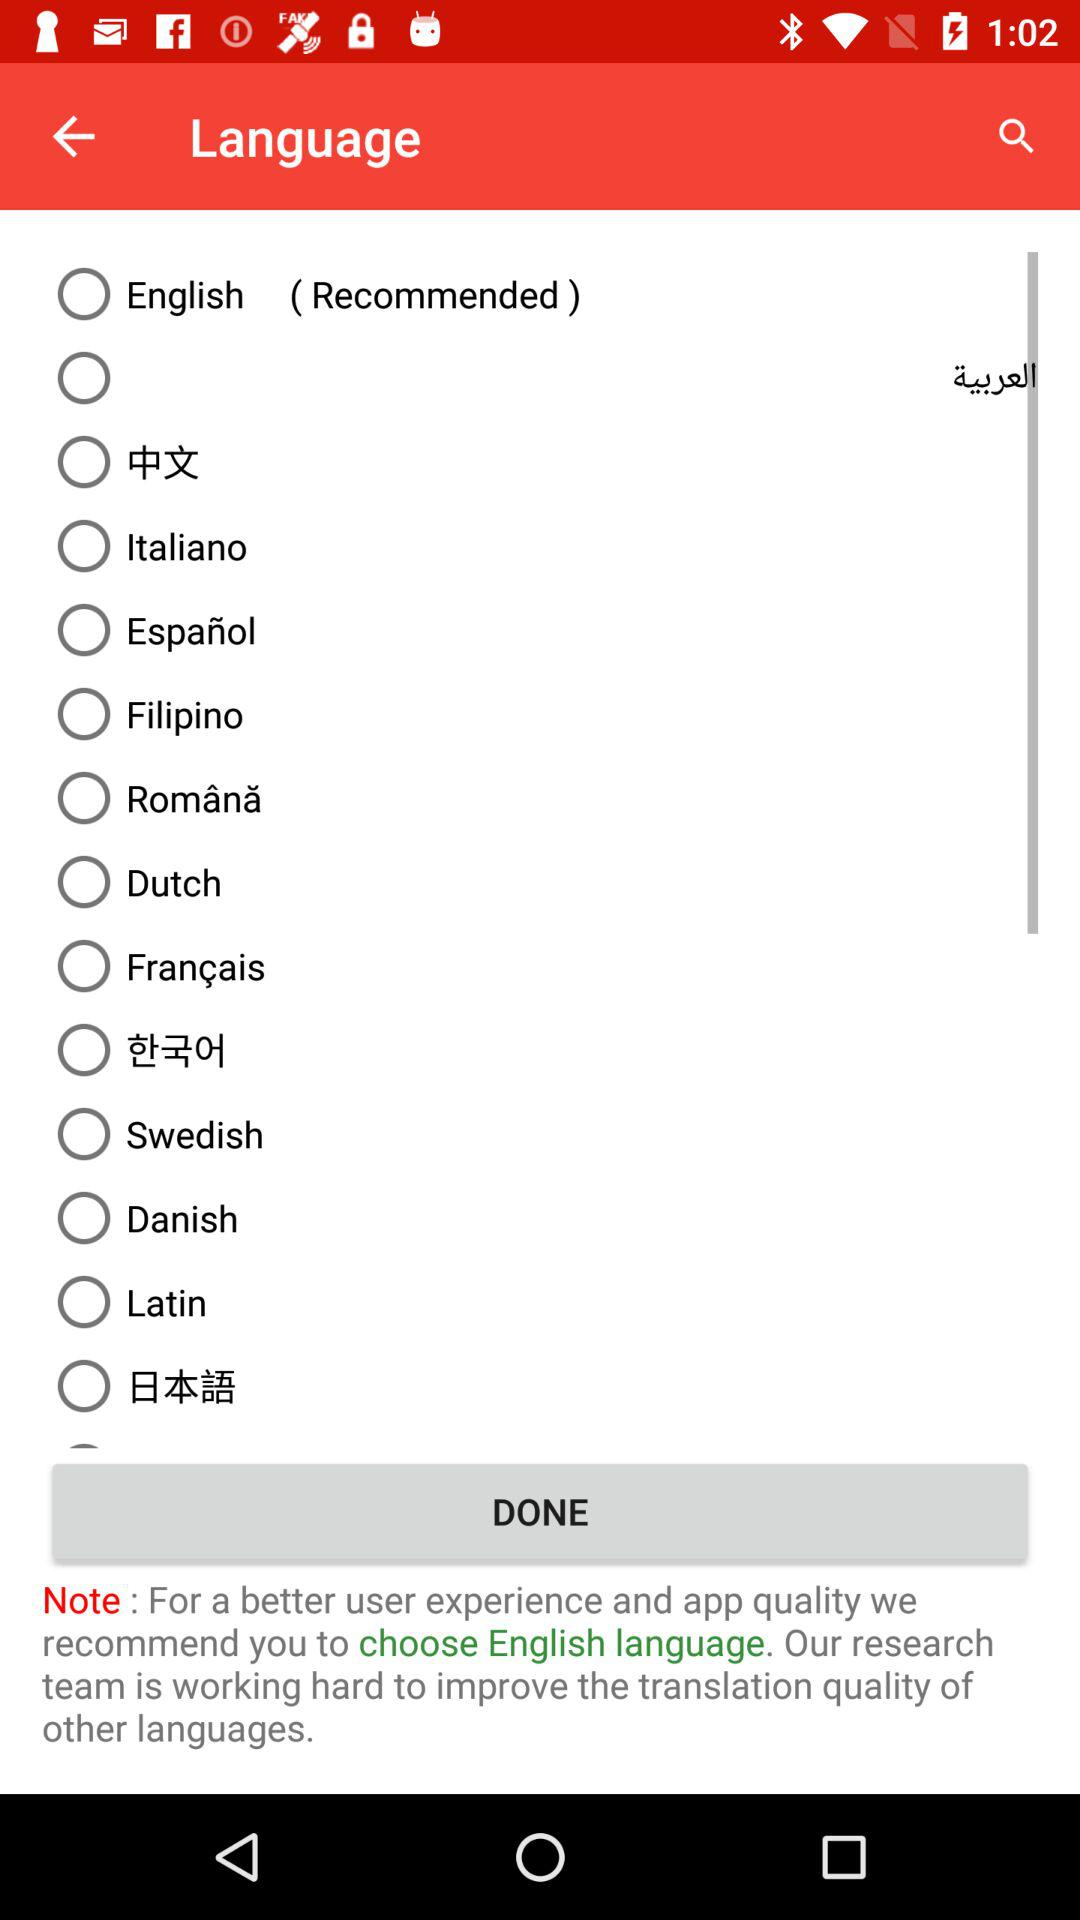Is Dutch language selected?
When the provided information is insufficient, respond with <no answer>. <no answer> 